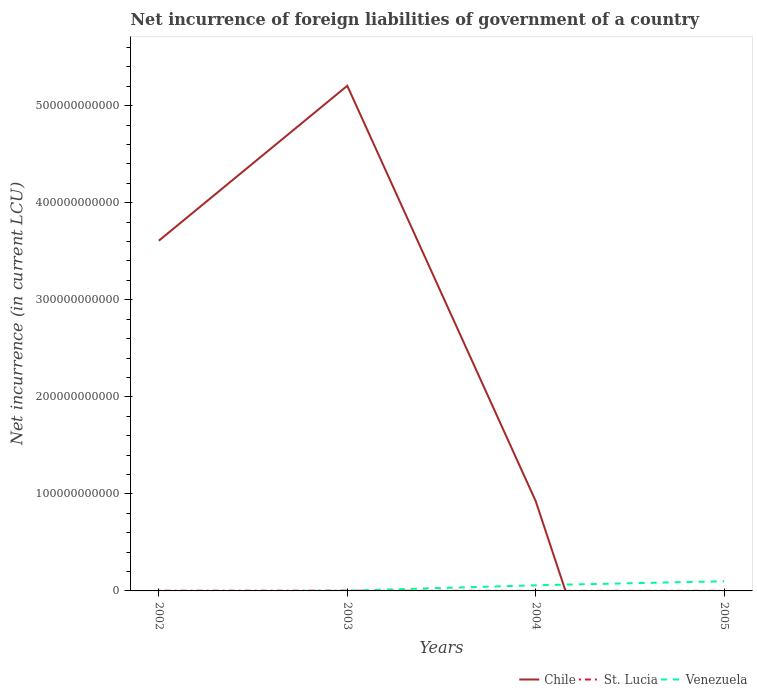How many different coloured lines are there?
Provide a succinct answer. 3. Is the number of lines equal to the number of legend labels?
Give a very brief answer. No. Across all years, what is the maximum net incurrence of foreign liabilities in Venezuela?
Keep it short and to the point. 0. What is the total net incurrence of foreign liabilities in St. Lucia in the graph?
Offer a very short reply. 1.08e+08. What is the difference between the highest and the second highest net incurrence of foreign liabilities in Venezuela?
Ensure brevity in your answer.  9.96e+09. How many lines are there?
Your response must be concise. 3. What is the difference between two consecutive major ticks on the Y-axis?
Your response must be concise. 1.00e+11. Does the graph contain any zero values?
Your answer should be compact. Yes. Where does the legend appear in the graph?
Ensure brevity in your answer.  Bottom right. What is the title of the graph?
Ensure brevity in your answer.  Net incurrence of foreign liabilities of government of a country. What is the label or title of the Y-axis?
Provide a short and direct response. Net incurrence (in current LCU). What is the Net incurrence (in current LCU) of Chile in 2002?
Your answer should be compact. 3.61e+11. What is the Net incurrence (in current LCU) in St. Lucia in 2002?
Give a very brief answer. 2.08e+08. What is the Net incurrence (in current LCU) in Chile in 2003?
Your answer should be compact. 5.21e+11. What is the Net incurrence (in current LCU) of St. Lucia in 2003?
Give a very brief answer. 2.39e+08. What is the Net incurrence (in current LCU) in Venezuela in 2003?
Offer a very short reply. 2.22e+08. What is the Net incurrence (in current LCU) of Chile in 2004?
Keep it short and to the point. 9.24e+1. What is the Net incurrence (in current LCU) of St. Lucia in 2004?
Your answer should be compact. 4.89e+07. What is the Net incurrence (in current LCU) of Venezuela in 2004?
Offer a very short reply. 5.81e+09. What is the Net incurrence (in current LCU) of Chile in 2005?
Keep it short and to the point. 0. What is the Net incurrence (in current LCU) in St. Lucia in 2005?
Give a very brief answer. 9.99e+07. What is the Net incurrence (in current LCU) of Venezuela in 2005?
Offer a terse response. 9.96e+09. Across all years, what is the maximum Net incurrence (in current LCU) in Chile?
Make the answer very short. 5.21e+11. Across all years, what is the maximum Net incurrence (in current LCU) of St. Lucia?
Keep it short and to the point. 2.39e+08. Across all years, what is the maximum Net incurrence (in current LCU) of Venezuela?
Give a very brief answer. 9.96e+09. Across all years, what is the minimum Net incurrence (in current LCU) of Chile?
Your answer should be compact. 0. Across all years, what is the minimum Net incurrence (in current LCU) in St. Lucia?
Your response must be concise. 4.89e+07. What is the total Net incurrence (in current LCU) of Chile in the graph?
Provide a short and direct response. 9.74e+11. What is the total Net incurrence (in current LCU) of St. Lucia in the graph?
Give a very brief answer. 5.96e+08. What is the total Net incurrence (in current LCU) of Venezuela in the graph?
Your answer should be compact. 1.60e+1. What is the difference between the Net incurrence (in current LCU) of Chile in 2002 and that in 2003?
Make the answer very short. -1.60e+11. What is the difference between the Net incurrence (in current LCU) of St. Lucia in 2002 and that in 2003?
Your response must be concise. -3.08e+07. What is the difference between the Net incurrence (in current LCU) in Chile in 2002 and that in 2004?
Make the answer very short. 2.68e+11. What is the difference between the Net incurrence (in current LCU) of St. Lucia in 2002 and that in 2004?
Your answer should be very brief. 1.59e+08. What is the difference between the Net incurrence (in current LCU) of St. Lucia in 2002 and that in 2005?
Provide a succinct answer. 1.08e+08. What is the difference between the Net incurrence (in current LCU) of Chile in 2003 and that in 2004?
Ensure brevity in your answer.  4.28e+11. What is the difference between the Net incurrence (in current LCU) in St. Lucia in 2003 and that in 2004?
Keep it short and to the point. 1.90e+08. What is the difference between the Net incurrence (in current LCU) of Venezuela in 2003 and that in 2004?
Provide a short and direct response. -5.59e+09. What is the difference between the Net incurrence (in current LCU) in St. Lucia in 2003 and that in 2005?
Make the answer very short. 1.39e+08. What is the difference between the Net incurrence (in current LCU) in Venezuela in 2003 and that in 2005?
Make the answer very short. -9.74e+09. What is the difference between the Net incurrence (in current LCU) in St. Lucia in 2004 and that in 2005?
Offer a terse response. -5.10e+07. What is the difference between the Net incurrence (in current LCU) in Venezuela in 2004 and that in 2005?
Keep it short and to the point. -4.15e+09. What is the difference between the Net incurrence (in current LCU) of Chile in 2002 and the Net incurrence (in current LCU) of St. Lucia in 2003?
Offer a terse response. 3.61e+11. What is the difference between the Net incurrence (in current LCU) in Chile in 2002 and the Net incurrence (in current LCU) in Venezuela in 2003?
Your response must be concise. 3.61e+11. What is the difference between the Net incurrence (in current LCU) of St. Lucia in 2002 and the Net incurrence (in current LCU) of Venezuela in 2003?
Offer a terse response. -1.35e+07. What is the difference between the Net incurrence (in current LCU) in Chile in 2002 and the Net incurrence (in current LCU) in St. Lucia in 2004?
Make the answer very short. 3.61e+11. What is the difference between the Net incurrence (in current LCU) in Chile in 2002 and the Net incurrence (in current LCU) in Venezuela in 2004?
Your answer should be compact. 3.55e+11. What is the difference between the Net incurrence (in current LCU) in St. Lucia in 2002 and the Net incurrence (in current LCU) in Venezuela in 2004?
Your answer should be compact. -5.61e+09. What is the difference between the Net incurrence (in current LCU) in Chile in 2002 and the Net incurrence (in current LCU) in St. Lucia in 2005?
Your response must be concise. 3.61e+11. What is the difference between the Net incurrence (in current LCU) of Chile in 2002 and the Net incurrence (in current LCU) of Venezuela in 2005?
Keep it short and to the point. 3.51e+11. What is the difference between the Net incurrence (in current LCU) in St. Lucia in 2002 and the Net incurrence (in current LCU) in Venezuela in 2005?
Offer a very short reply. -9.75e+09. What is the difference between the Net incurrence (in current LCU) in Chile in 2003 and the Net incurrence (in current LCU) in St. Lucia in 2004?
Provide a succinct answer. 5.21e+11. What is the difference between the Net incurrence (in current LCU) of Chile in 2003 and the Net incurrence (in current LCU) of Venezuela in 2004?
Offer a terse response. 5.15e+11. What is the difference between the Net incurrence (in current LCU) of St. Lucia in 2003 and the Net incurrence (in current LCU) of Venezuela in 2004?
Offer a terse response. -5.58e+09. What is the difference between the Net incurrence (in current LCU) in Chile in 2003 and the Net incurrence (in current LCU) in St. Lucia in 2005?
Provide a succinct answer. 5.20e+11. What is the difference between the Net incurrence (in current LCU) in Chile in 2003 and the Net incurrence (in current LCU) in Venezuela in 2005?
Offer a very short reply. 5.11e+11. What is the difference between the Net incurrence (in current LCU) of St. Lucia in 2003 and the Net incurrence (in current LCU) of Venezuela in 2005?
Keep it short and to the point. -9.72e+09. What is the difference between the Net incurrence (in current LCU) in Chile in 2004 and the Net incurrence (in current LCU) in St. Lucia in 2005?
Your response must be concise. 9.23e+1. What is the difference between the Net incurrence (in current LCU) of Chile in 2004 and the Net incurrence (in current LCU) of Venezuela in 2005?
Your answer should be compact. 8.24e+1. What is the difference between the Net incurrence (in current LCU) in St. Lucia in 2004 and the Net incurrence (in current LCU) in Venezuela in 2005?
Offer a terse response. -9.91e+09. What is the average Net incurrence (in current LCU) in Chile per year?
Your answer should be compact. 2.43e+11. What is the average Net incurrence (in current LCU) in St. Lucia per year?
Give a very brief answer. 1.49e+08. What is the average Net incurrence (in current LCU) in Venezuela per year?
Provide a succinct answer. 4.00e+09. In the year 2002, what is the difference between the Net incurrence (in current LCU) in Chile and Net incurrence (in current LCU) in St. Lucia?
Your response must be concise. 3.61e+11. In the year 2003, what is the difference between the Net incurrence (in current LCU) in Chile and Net incurrence (in current LCU) in St. Lucia?
Your answer should be compact. 5.20e+11. In the year 2003, what is the difference between the Net incurrence (in current LCU) of Chile and Net incurrence (in current LCU) of Venezuela?
Make the answer very short. 5.20e+11. In the year 2003, what is the difference between the Net incurrence (in current LCU) of St. Lucia and Net incurrence (in current LCU) of Venezuela?
Give a very brief answer. 1.73e+07. In the year 2004, what is the difference between the Net incurrence (in current LCU) of Chile and Net incurrence (in current LCU) of St. Lucia?
Your answer should be very brief. 9.24e+1. In the year 2004, what is the difference between the Net incurrence (in current LCU) in Chile and Net incurrence (in current LCU) in Venezuela?
Offer a terse response. 8.66e+1. In the year 2004, what is the difference between the Net incurrence (in current LCU) of St. Lucia and Net incurrence (in current LCU) of Venezuela?
Give a very brief answer. -5.77e+09. In the year 2005, what is the difference between the Net incurrence (in current LCU) of St. Lucia and Net incurrence (in current LCU) of Venezuela?
Your response must be concise. -9.86e+09. What is the ratio of the Net incurrence (in current LCU) in Chile in 2002 to that in 2003?
Provide a succinct answer. 0.69. What is the ratio of the Net incurrence (in current LCU) of St. Lucia in 2002 to that in 2003?
Offer a very short reply. 0.87. What is the ratio of the Net incurrence (in current LCU) in Chile in 2002 to that in 2004?
Keep it short and to the point. 3.91. What is the ratio of the Net incurrence (in current LCU) in St. Lucia in 2002 to that in 2004?
Offer a terse response. 4.26. What is the ratio of the Net incurrence (in current LCU) in St. Lucia in 2002 to that in 2005?
Provide a succinct answer. 2.09. What is the ratio of the Net incurrence (in current LCU) in Chile in 2003 to that in 2004?
Provide a short and direct response. 5.63. What is the ratio of the Net incurrence (in current LCU) in St. Lucia in 2003 to that in 2004?
Keep it short and to the point. 4.89. What is the ratio of the Net incurrence (in current LCU) of Venezuela in 2003 to that in 2004?
Provide a succinct answer. 0.04. What is the ratio of the Net incurrence (in current LCU) in St. Lucia in 2003 to that in 2005?
Your answer should be compact. 2.39. What is the ratio of the Net incurrence (in current LCU) in Venezuela in 2003 to that in 2005?
Give a very brief answer. 0.02. What is the ratio of the Net incurrence (in current LCU) in St. Lucia in 2004 to that in 2005?
Your response must be concise. 0.49. What is the ratio of the Net incurrence (in current LCU) in Venezuela in 2004 to that in 2005?
Your answer should be very brief. 0.58. What is the difference between the highest and the second highest Net incurrence (in current LCU) of Chile?
Ensure brevity in your answer.  1.60e+11. What is the difference between the highest and the second highest Net incurrence (in current LCU) of St. Lucia?
Your answer should be compact. 3.08e+07. What is the difference between the highest and the second highest Net incurrence (in current LCU) in Venezuela?
Give a very brief answer. 4.15e+09. What is the difference between the highest and the lowest Net incurrence (in current LCU) in Chile?
Provide a short and direct response. 5.21e+11. What is the difference between the highest and the lowest Net incurrence (in current LCU) of St. Lucia?
Ensure brevity in your answer.  1.90e+08. What is the difference between the highest and the lowest Net incurrence (in current LCU) in Venezuela?
Make the answer very short. 9.96e+09. 